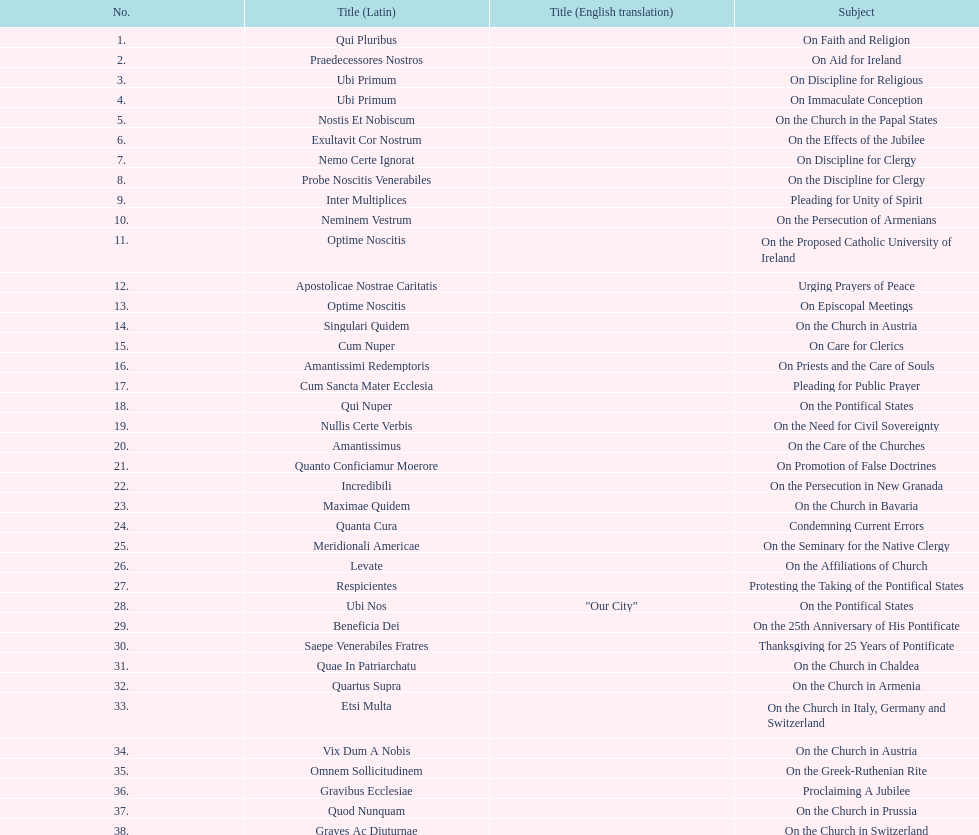Latin title of the encyclical before the encyclical with the subject "on the church in bavaria" Incredibili. 